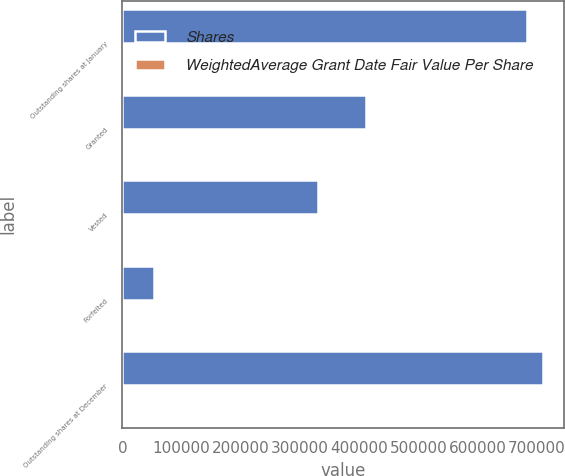Convert chart to OTSL. <chart><loc_0><loc_0><loc_500><loc_500><stacked_bar_chart><ecel><fcel>Outstanding shares at January<fcel>Granted<fcel>Vested<fcel>Forfeited<fcel>Outstanding shares at December<nl><fcel>Shares<fcel>683474<fcel>410787<fcel>330816<fcel>53834<fcel>709611<nl><fcel>WeightedAverage Grant Date Fair Value Per Share<fcel>74.8<fcel>70.71<fcel>73.61<fcel>75.63<fcel>72.92<nl></chart> 